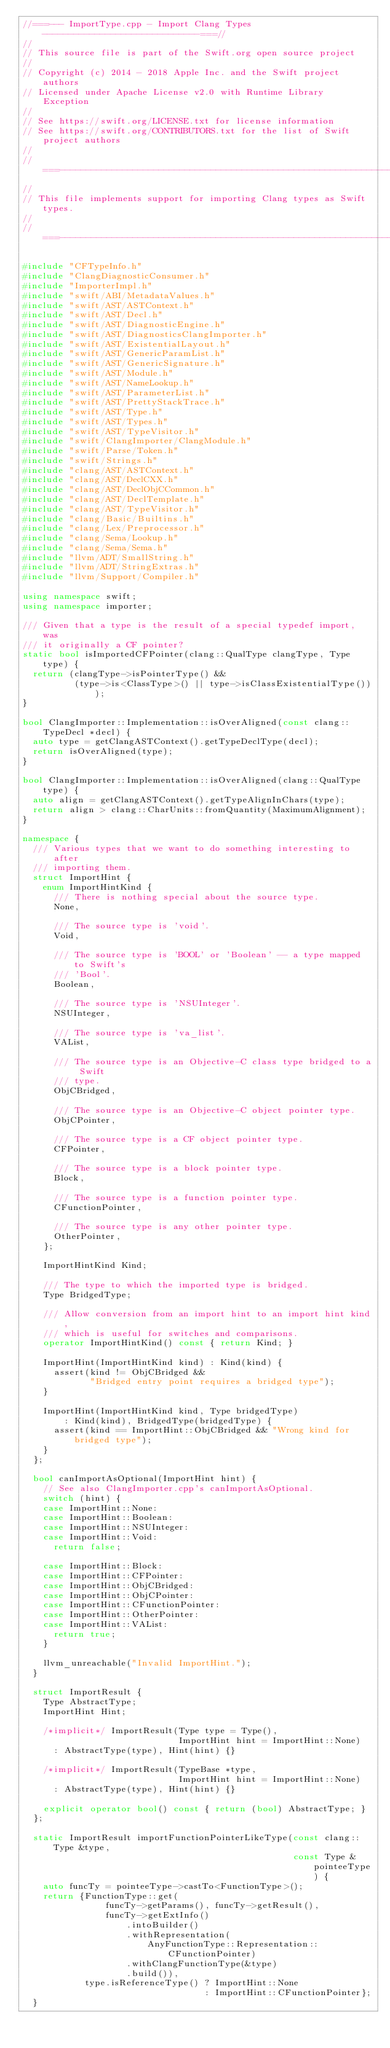Convert code to text. <code><loc_0><loc_0><loc_500><loc_500><_C++_>//===--- ImportType.cpp - Import Clang Types ------------------------------===//
//
// This source file is part of the Swift.org open source project
//
// Copyright (c) 2014 - 2018 Apple Inc. and the Swift project authors
// Licensed under Apache License v2.0 with Runtime Library Exception
//
// See https://swift.org/LICENSE.txt for license information
// See https://swift.org/CONTRIBUTORS.txt for the list of Swift project authors
//
//===----------------------------------------------------------------------===//
//
// This file implements support for importing Clang types as Swift types.
//
//===----------------------------------------------------------------------===//

#include "CFTypeInfo.h"
#include "ClangDiagnosticConsumer.h"
#include "ImporterImpl.h"
#include "swift/ABI/MetadataValues.h"
#include "swift/AST/ASTContext.h"
#include "swift/AST/Decl.h"
#include "swift/AST/DiagnosticEngine.h"
#include "swift/AST/DiagnosticsClangImporter.h"
#include "swift/AST/ExistentialLayout.h"
#include "swift/AST/GenericParamList.h"
#include "swift/AST/GenericSignature.h"
#include "swift/AST/Module.h"
#include "swift/AST/NameLookup.h"
#include "swift/AST/ParameterList.h"
#include "swift/AST/PrettyStackTrace.h"
#include "swift/AST/Type.h"
#include "swift/AST/Types.h"
#include "swift/AST/TypeVisitor.h"
#include "swift/ClangImporter/ClangModule.h"
#include "swift/Parse/Token.h"
#include "swift/Strings.h"
#include "clang/AST/ASTContext.h"
#include "clang/AST/DeclCXX.h"
#include "clang/AST/DeclObjCCommon.h"
#include "clang/AST/DeclTemplate.h"
#include "clang/AST/TypeVisitor.h"
#include "clang/Basic/Builtins.h"
#include "clang/Lex/Preprocessor.h"
#include "clang/Sema/Lookup.h"
#include "clang/Sema/Sema.h"
#include "llvm/ADT/SmallString.h"
#include "llvm/ADT/StringExtras.h"
#include "llvm/Support/Compiler.h"

using namespace swift;
using namespace importer;

/// Given that a type is the result of a special typedef import, was
/// it originally a CF pointer?
static bool isImportedCFPointer(clang::QualType clangType, Type type) {
  return (clangType->isPointerType() &&
          (type->is<ClassType>() || type->isClassExistentialType()));
}

bool ClangImporter::Implementation::isOverAligned(const clang::TypeDecl *decl) {
  auto type = getClangASTContext().getTypeDeclType(decl);
  return isOverAligned(type);
}

bool ClangImporter::Implementation::isOverAligned(clang::QualType type) {
  auto align = getClangASTContext().getTypeAlignInChars(type);
  return align > clang::CharUnits::fromQuantity(MaximumAlignment);
}

namespace {
  /// Various types that we want to do something interesting to after
  /// importing them.
  struct ImportHint {
    enum ImportHintKind {
      /// There is nothing special about the source type.
      None,

      /// The source type is 'void'.
      Void,

      /// The source type is 'BOOL' or 'Boolean' -- a type mapped to Swift's
      /// 'Bool'.
      Boolean,

      /// The source type is 'NSUInteger'.
      NSUInteger,

      /// The source type is 'va_list'.
      VAList,

      /// The source type is an Objective-C class type bridged to a Swift
      /// type.
      ObjCBridged,

      /// The source type is an Objective-C object pointer type.
      ObjCPointer,

      /// The source type is a CF object pointer type.
      CFPointer,

      /// The source type is a block pointer type.
      Block,

      /// The source type is a function pointer type.
      CFunctionPointer,

      /// The source type is any other pointer type.
      OtherPointer,
    };

    ImportHintKind Kind;

    /// The type to which the imported type is bridged.
    Type BridgedType;

    /// Allow conversion from an import hint to an import hint kind,
    /// which is useful for switches and comparisons.
    operator ImportHintKind() const { return Kind; }

    ImportHint(ImportHintKind kind) : Kind(kind) {
      assert(kind != ObjCBridged &&
             "Bridged entry point requires a bridged type");
    }

    ImportHint(ImportHintKind kind, Type bridgedType)
        : Kind(kind), BridgedType(bridgedType) {
      assert(kind == ImportHint::ObjCBridged && "Wrong kind for bridged type");
    }
  };

  bool canImportAsOptional(ImportHint hint) {
    // See also ClangImporter.cpp's canImportAsOptional.
    switch (hint) {
    case ImportHint::None:
    case ImportHint::Boolean:
    case ImportHint::NSUInteger:
    case ImportHint::Void:
      return false;

    case ImportHint::Block:
    case ImportHint::CFPointer:
    case ImportHint::ObjCBridged:
    case ImportHint::ObjCPointer:
    case ImportHint::CFunctionPointer:
    case ImportHint::OtherPointer:
    case ImportHint::VAList:
      return true;
    }

    llvm_unreachable("Invalid ImportHint.");
  }

  struct ImportResult {
    Type AbstractType;
    ImportHint Hint;

    /*implicit*/ ImportResult(Type type = Type(),
                              ImportHint hint = ImportHint::None)
      : AbstractType(type), Hint(hint) {}

    /*implicit*/ ImportResult(TypeBase *type,
                              ImportHint hint = ImportHint::None)
      : AbstractType(type), Hint(hint) {}

    explicit operator bool() const { return (bool) AbstractType; }
  };

  static ImportResult importFunctionPointerLikeType(const clang::Type &type,
                                                    const Type &pointeeType) {
    auto funcTy = pointeeType->castTo<FunctionType>();
    return {FunctionType::get(
                funcTy->getParams(), funcTy->getResult(),
                funcTy->getExtInfo()
                    .intoBuilder()
                    .withRepresentation(
                        AnyFunctionType::Representation::CFunctionPointer)
                    .withClangFunctionType(&type)
                    .build()),
            type.isReferenceType() ? ImportHint::None
                                   : ImportHint::CFunctionPointer};
  }
</code> 